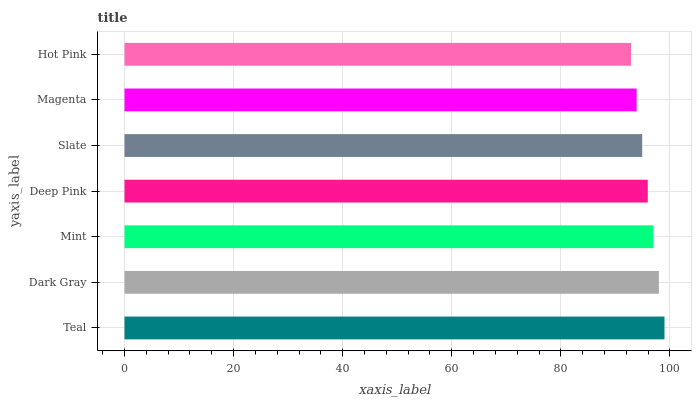Is Hot Pink the minimum?
Answer yes or no. Yes. Is Teal the maximum?
Answer yes or no. Yes. Is Dark Gray the minimum?
Answer yes or no. No. Is Dark Gray the maximum?
Answer yes or no. No. Is Teal greater than Dark Gray?
Answer yes or no. Yes. Is Dark Gray less than Teal?
Answer yes or no. Yes. Is Dark Gray greater than Teal?
Answer yes or no. No. Is Teal less than Dark Gray?
Answer yes or no. No. Is Deep Pink the high median?
Answer yes or no. Yes. Is Deep Pink the low median?
Answer yes or no. Yes. Is Dark Gray the high median?
Answer yes or no. No. Is Mint the low median?
Answer yes or no. No. 